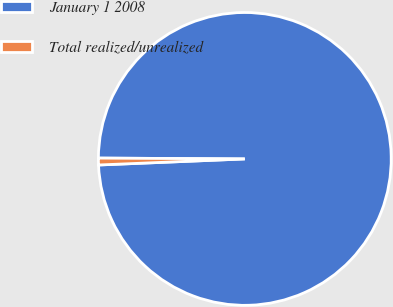Convert chart to OTSL. <chart><loc_0><loc_0><loc_500><loc_500><pie_chart><fcel>January 1 2008<fcel>Total realized/unrealized<nl><fcel>99.25%<fcel>0.75%<nl></chart> 